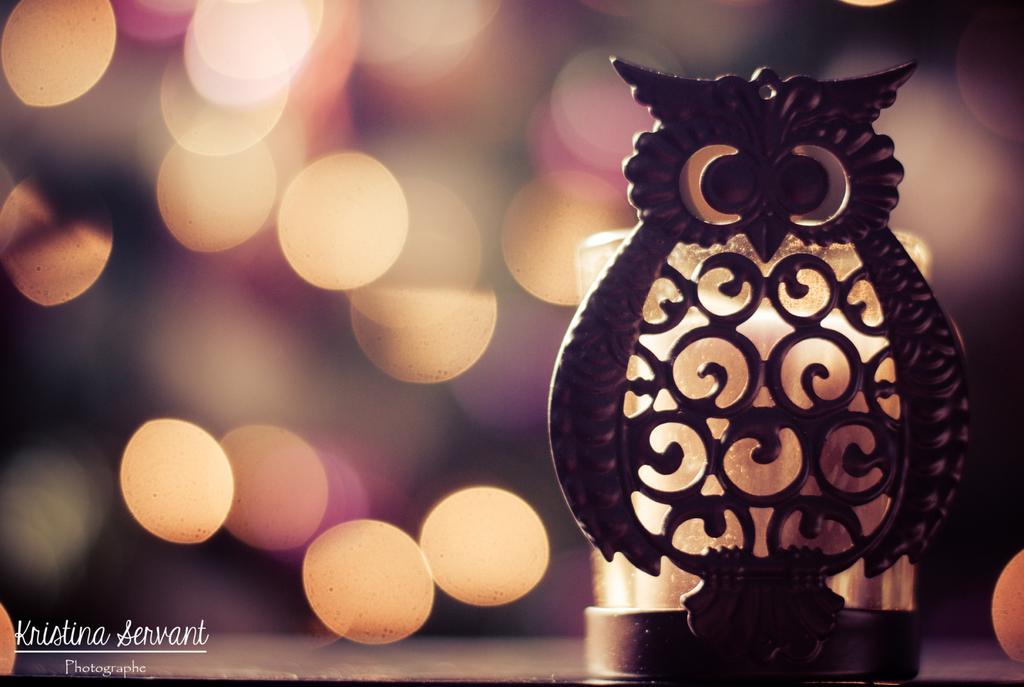How would you summarize this image in a sentence or two? In this picture we can see the object it looks like a owl, behind we can see some lights. 